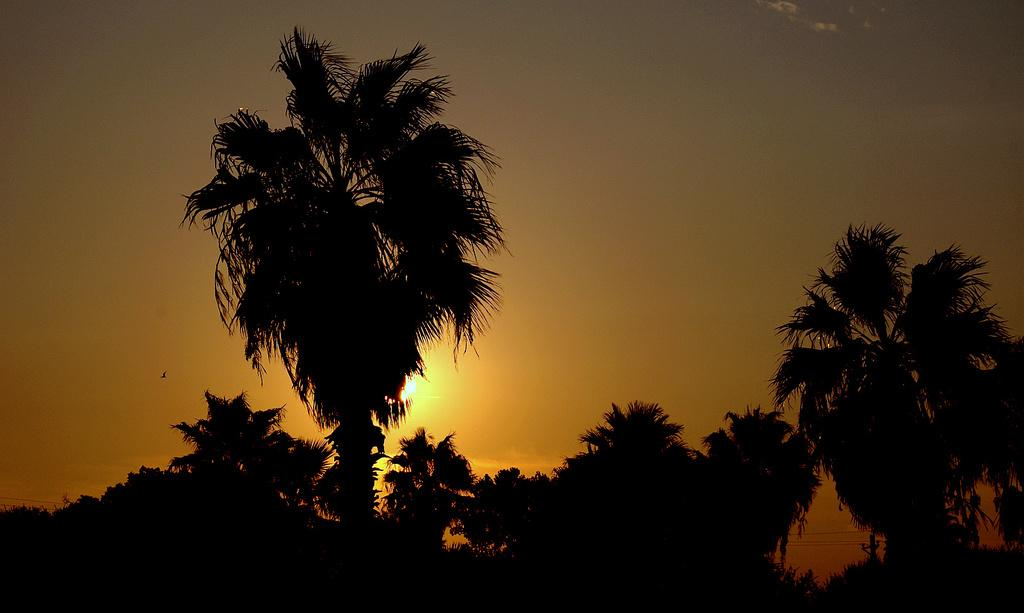What is located in the foreground of the image? There is a group of trees in the foreground of the image. What can be seen in the sky on the left side of the image? A bird is flying in the sky on the left side of the image. What is visible in the background of the image? The sun is visible in the sky in the background of the image. Where is the doctor standing in the image? There is no doctor present in the image. Is there a stream visible in the image? There is no stream visible in the image. 